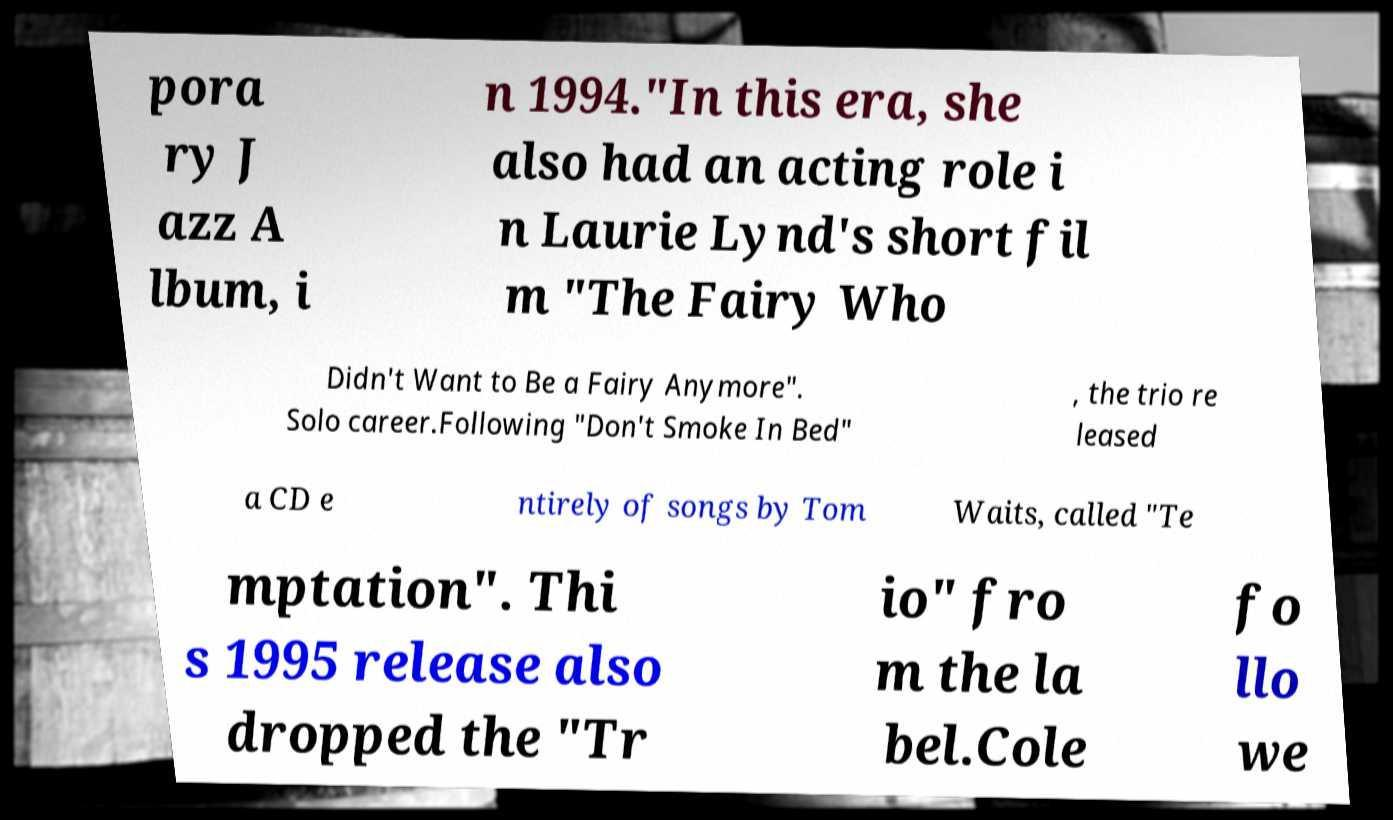Can you read and provide the text displayed in the image?This photo seems to have some interesting text. Can you extract and type it out for me? pora ry J azz A lbum, i n 1994."In this era, she also had an acting role i n Laurie Lynd's short fil m "The Fairy Who Didn't Want to Be a Fairy Anymore". Solo career.Following "Don't Smoke In Bed" , the trio re leased a CD e ntirely of songs by Tom Waits, called "Te mptation". Thi s 1995 release also dropped the "Tr io" fro m the la bel.Cole fo llo we 